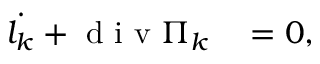Convert formula to latex. <formula><loc_0><loc_0><loc_500><loc_500>\begin{array} { r l } { \dot { l _ { k } } + d i v \Pi _ { k } } & = 0 , } \end{array}</formula> 